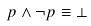<formula> <loc_0><loc_0><loc_500><loc_500>p \wedge \neg p \equiv \bot</formula> 